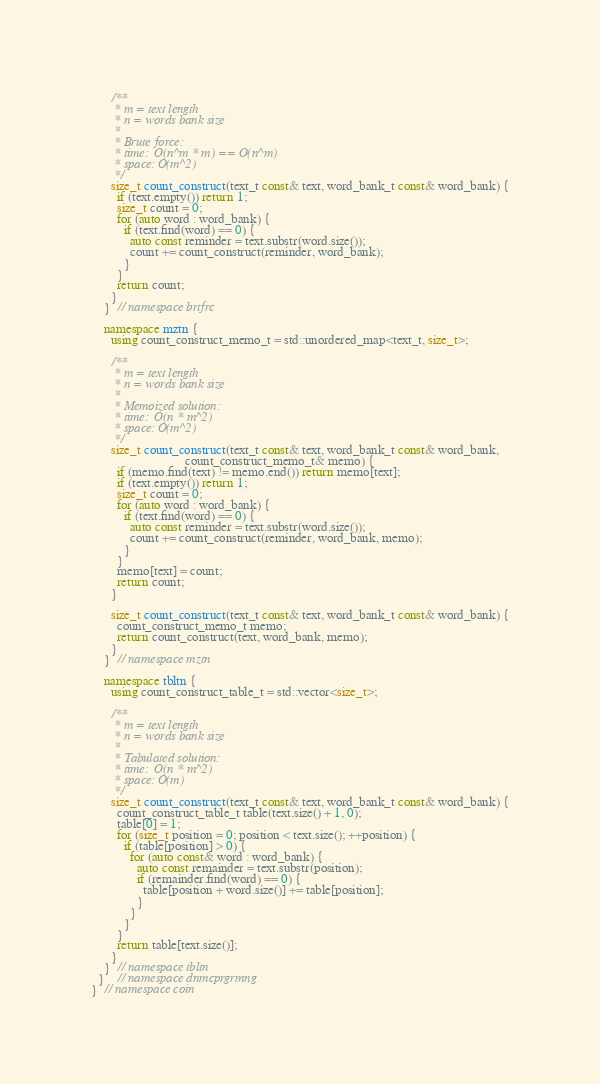Convert code to text. <code><loc_0><loc_0><loc_500><loc_500><_C++_>      /**
       * m = text length
       * n = words bank size
       *
       * Brute force:
       * time:  O(n^m * m) == O(n^m)
       * space: O(m^2)
       */
      size_t count_construct(text_t const& text, word_bank_t const& word_bank) {
        if (text.empty()) return 1;
        size_t count = 0;
        for (auto word : word_bank) {
          if (text.find(word) == 0) {
            auto const reminder = text.substr(word.size());
            count += count_construct(reminder, word_bank);
          }
        }
        return count;
      }
    }  // namespace brtfrc

    namespace mztn {
      using count_construct_memo_t = std::unordered_map<text_t, size_t>;

      /**
       * m = text length
       * n = words bank size
       *
       * Memoized solution:
       * time:  O(n * m^2)
       * space: O(m^2)
       */
      size_t count_construct(text_t const& text, word_bank_t const& word_bank,
                             count_construct_memo_t& memo) {
        if (memo.find(text) != memo.end()) return memo[text];
        if (text.empty()) return 1;
        size_t count = 0;
        for (auto word : word_bank) {
          if (text.find(word) == 0) {
            auto const reminder = text.substr(word.size());
            count += count_construct(reminder, word_bank, memo);
          }
        }
        memo[text] = count;
        return count;
      }

      size_t count_construct(text_t const& text, word_bank_t const& word_bank) {
        count_construct_memo_t memo;
        return count_construct(text, word_bank, memo);
      }
    }  // namespace mztn

    namespace tbltn {
      using count_construct_table_t = std::vector<size_t>;

      /**
       * m = text length
       * n = words bank size
       *
       * Tabulated solution:
       * time:  O(n * m^2)
       * space: O(m)
       */
      size_t count_construct(text_t const& text, word_bank_t const& word_bank) {
        count_construct_table_t table(text.size() + 1, 0);
        table[0] = 1;
        for (size_t position = 0; position < text.size(); ++position) {
          if (table[position] > 0) {
            for (auto const& word : word_bank) {
              auto const remainder = text.substr(position);
              if (remainder.find(word) == 0) {
                table[position + word.size()] += table[position];
              }
            }
          }
        }
        return table[text.size()];
      }
    }  // namespace tbltn
  }    // namespace dnmcprgrmng
}  // namespace coin
</code> 